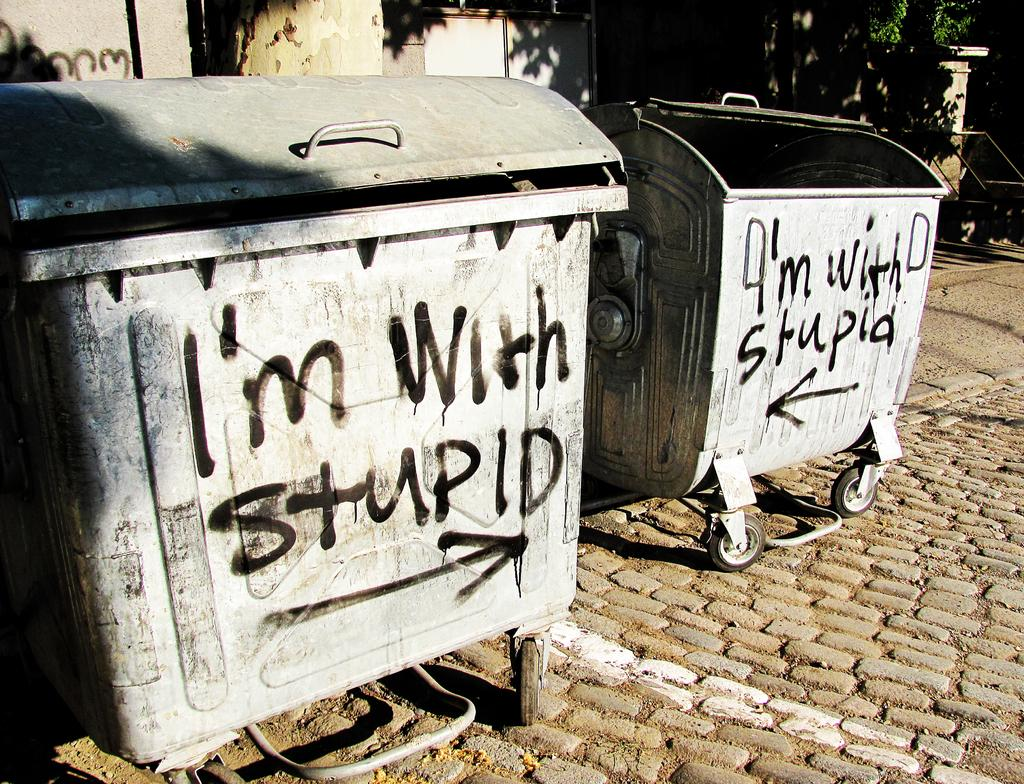<image>
Give a short and clear explanation of the subsequent image. A dumpster has "I'm with stupid" spray panted on it. 